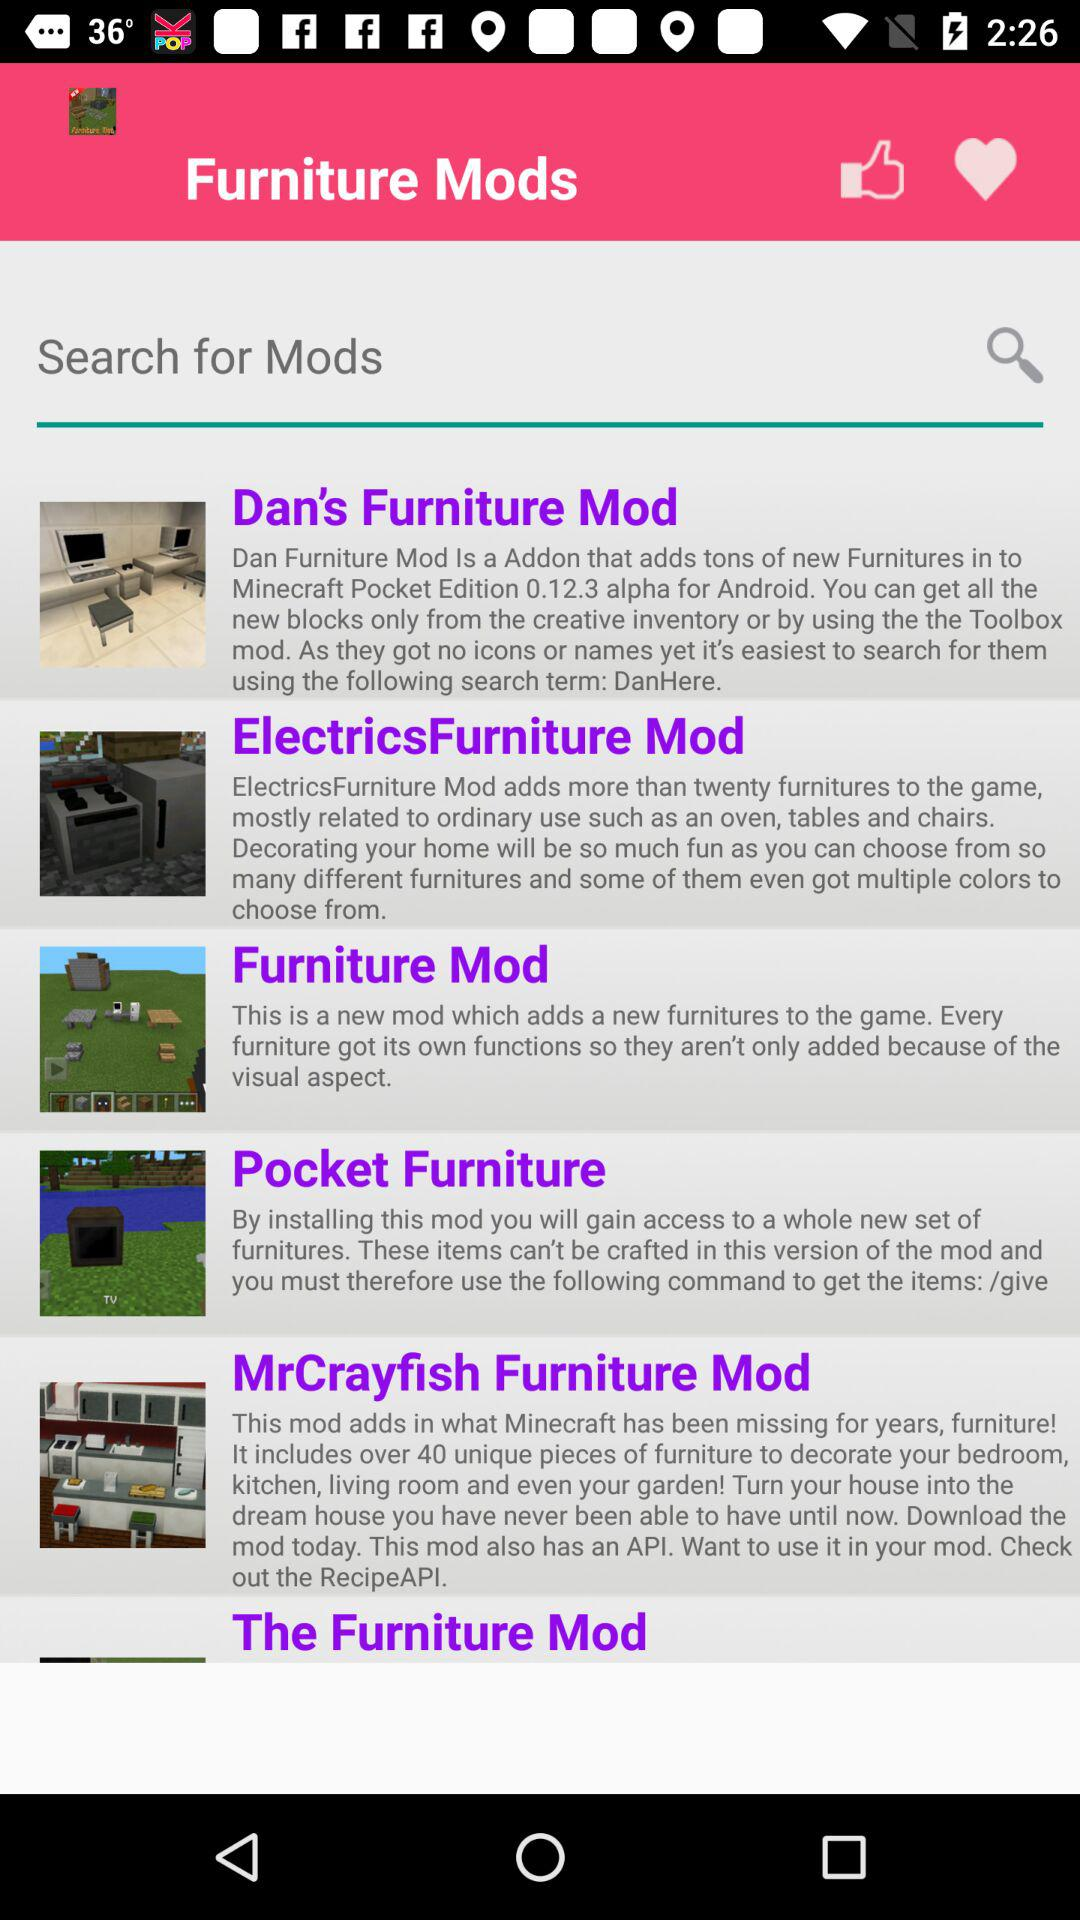What is the description of "The Furniture Mod"?
When the provided information is insufficient, respond with <no answer>. <no answer> 